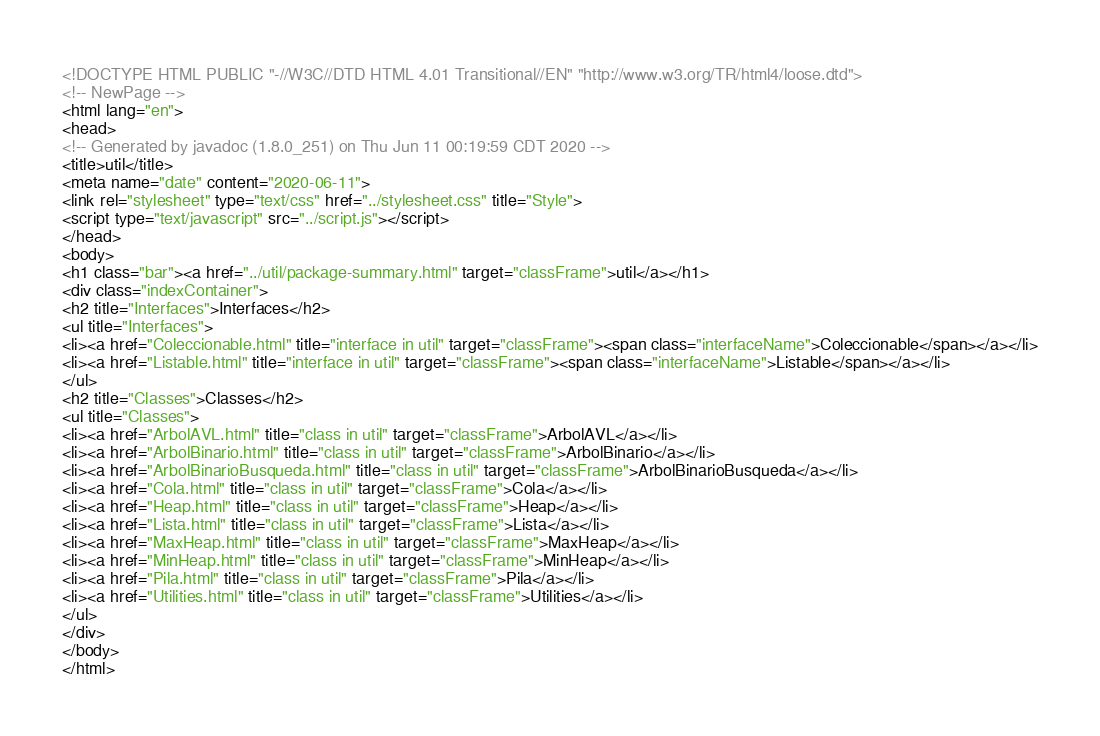<code> <loc_0><loc_0><loc_500><loc_500><_HTML_><!DOCTYPE HTML PUBLIC "-//W3C//DTD HTML 4.01 Transitional//EN" "http://www.w3.org/TR/html4/loose.dtd">
<!-- NewPage -->
<html lang="en">
<head>
<!-- Generated by javadoc (1.8.0_251) on Thu Jun 11 00:19:59 CDT 2020 -->
<title>util</title>
<meta name="date" content="2020-06-11">
<link rel="stylesheet" type="text/css" href="../stylesheet.css" title="Style">
<script type="text/javascript" src="../script.js"></script>
</head>
<body>
<h1 class="bar"><a href="../util/package-summary.html" target="classFrame">util</a></h1>
<div class="indexContainer">
<h2 title="Interfaces">Interfaces</h2>
<ul title="Interfaces">
<li><a href="Coleccionable.html" title="interface in util" target="classFrame"><span class="interfaceName">Coleccionable</span></a></li>
<li><a href="Listable.html" title="interface in util" target="classFrame"><span class="interfaceName">Listable</span></a></li>
</ul>
<h2 title="Classes">Classes</h2>
<ul title="Classes">
<li><a href="ArbolAVL.html" title="class in util" target="classFrame">ArbolAVL</a></li>
<li><a href="ArbolBinario.html" title="class in util" target="classFrame">ArbolBinario</a></li>
<li><a href="ArbolBinarioBusqueda.html" title="class in util" target="classFrame">ArbolBinarioBusqueda</a></li>
<li><a href="Cola.html" title="class in util" target="classFrame">Cola</a></li>
<li><a href="Heap.html" title="class in util" target="classFrame">Heap</a></li>
<li><a href="Lista.html" title="class in util" target="classFrame">Lista</a></li>
<li><a href="MaxHeap.html" title="class in util" target="classFrame">MaxHeap</a></li>
<li><a href="MinHeap.html" title="class in util" target="classFrame">MinHeap</a></li>
<li><a href="Pila.html" title="class in util" target="classFrame">Pila</a></li>
<li><a href="Utilities.html" title="class in util" target="classFrame">Utilities</a></li>
</ul>
</div>
</body>
</html>
</code> 